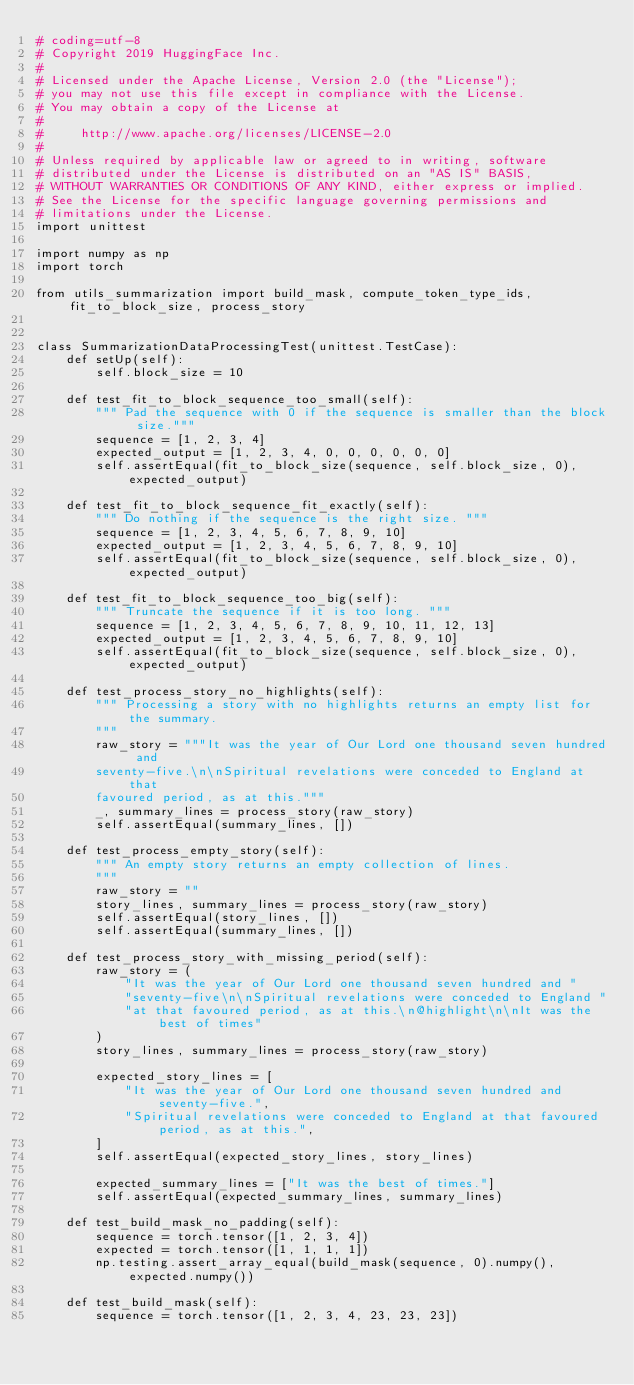Convert code to text. <code><loc_0><loc_0><loc_500><loc_500><_Python_># coding=utf-8
# Copyright 2019 HuggingFace Inc.
#
# Licensed under the Apache License, Version 2.0 (the "License");
# you may not use this file except in compliance with the License.
# You may obtain a copy of the License at
#
#     http://www.apache.org/licenses/LICENSE-2.0
#
# Unless required by applicable law or agreed to in writing, software
# distributed under the License is distributed on an "AS IS" BASIS,
# WITHOUT WARRANTIES OR CONDITIONS OF ANY KIND, either express or implied.
# See the License for the specific language governing permissions and
# limitations under the License.
import unittest

import numpy as np
import torch

from utils_summarization import build_mask, compute_token_type_ids, fit_to_block_size, process_story


class SummarizationDataProcessingTest(unittest.TestCase):
    def setUp(self):
        self.block_size = 10

    def test_fit_to_block_sequence_too_small(self):
        """ Pad the sequence with 0 if the sequence is smaller than the block size."""
        sequence = [1, 2, 3, 4]
        expected_output = [1, 2, 3, 4, 0, 0, 0, 0, 0, 0]
        self.assertEqual(fit_to_block_size(sequence, self.block_size, 0), expected_output)

    def test_fit_to_block_sequence_fit_exactly(self):
        """ Do nothing if the sequence is the right size. """
        sequence = [1, 2, 3, 4, 5, 6, 7, 8, 9, 10]
        expected_output = [1, 2, 3, 4, 5, 6, 7, 8, 9, 10]
        self.assertEqual(fit_to_block_size(sequence, self.block_size, 0), expected_output)

    def test_fit_to_block_sequence_too_big(self):
        """ Truncate the sequence if it is too long. """
        sequence = [1, 2, 3, 4, 5, 6, 7, 8, 9, 10, 11, 12, 13]
        expected_output = [1, 2, 3, 4, 5, 6, 7, 8, 9, 10]
        self.assertEqual(fit_to_block_size(sequence, self.block_size, 0), expected_output)

    def test_process_story_no_highlights(self):
        """ Processing a story with no highlights returns an empty list for the summary.
        """
        raw_story = """It was the year of Our Lord one thousand seven hundred and
        seventy-five.\n\nSpiritual revelations were conceded to England at that
        favoured period, as at this."""
        _, summary_lines = process_story(raw_story)
        self.assertEqual(summary_lines, [])

    def test_process_empty_story(self):
        """ An empty story returns an empty collection of lines.
        """
        raw_story = ""
        story_lines, summary_lines = process_story(raw_story)
        self.assertEqual(story_lines, [])
        self.assertEqual(summary_lines, [])

    def test_process_story_with_missing_period(self):
        raw_story = (
            "It was the year of Our Lord one thousand seven hundred and "
            "seventy-five\n\nSpiritual revelations were conceded to England "
            "at that favoured period, as at this.\n@highlight\n\nIt was the best of times"
        )
        story_lines, summary_lines = process_story(raw_story)

        expected_story_lines = [
            "It was the year of Our Lord one thousand seven hundred and seventy-five.",
            "Spiritual revelations were conceded to England at that favoured period, as at this.",
        ]
        self.assertEqual(expected_story_lines, story_lines)

        expected_summary_lines = ["It was the best of times."]
        self.assertEqual(expected_summary_lines, summary_lines)

    def test_build_mask_no_padding(self):
        sequence = torch.tensor([1, 2, 3, 4])
        expected = torch.tensor([1, 1, 1, 1])
        np.testing.assert_array_equal(build_mask(sequence, 0).numpy(), expected.numpy())

    def test_build_mask(self):
        sequence = torch.tensor([1, 2, 3, 4, 23, 23, 23])</code> 